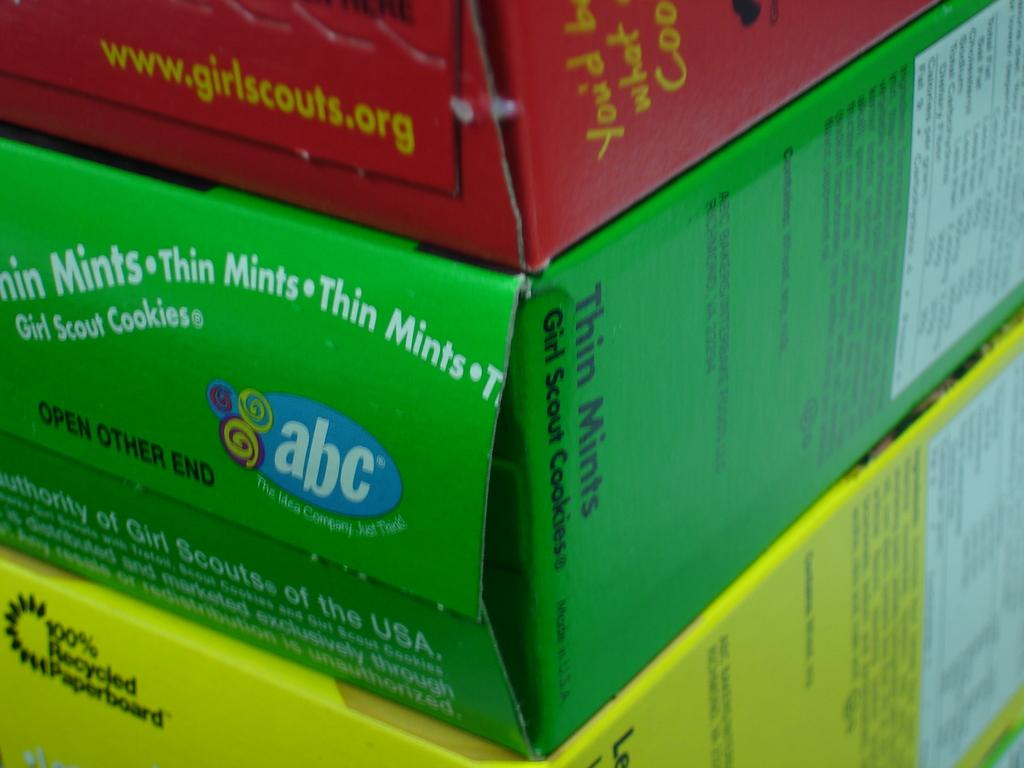<image>
Summarize the visual content of the image. Green box for Thin Mints Girl Scout Cookies between some other boxes. 